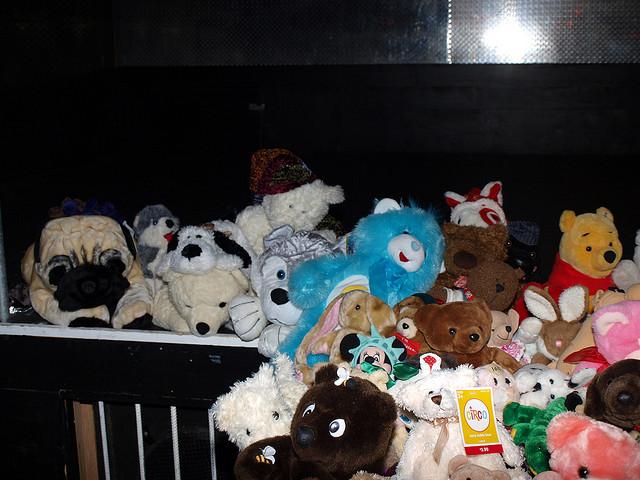How many stuffed animals are pictured?
Be succinct. 30. What is Minnie Mouse dressed as?
Answer briefly. Statue of liberty. What are the stuffed animals sitting on?
Write a very short answer. Bed. 